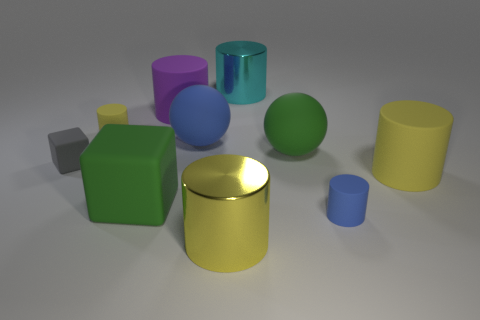The big rubber cylinder to the left of the yellow rubber object that is in front of the gray object is what color? The large cylinder to the left of the yellow one, in front of the gray object, has a vibrant purple hue, making it quite noticeable against the subtle tones of the other objects. 